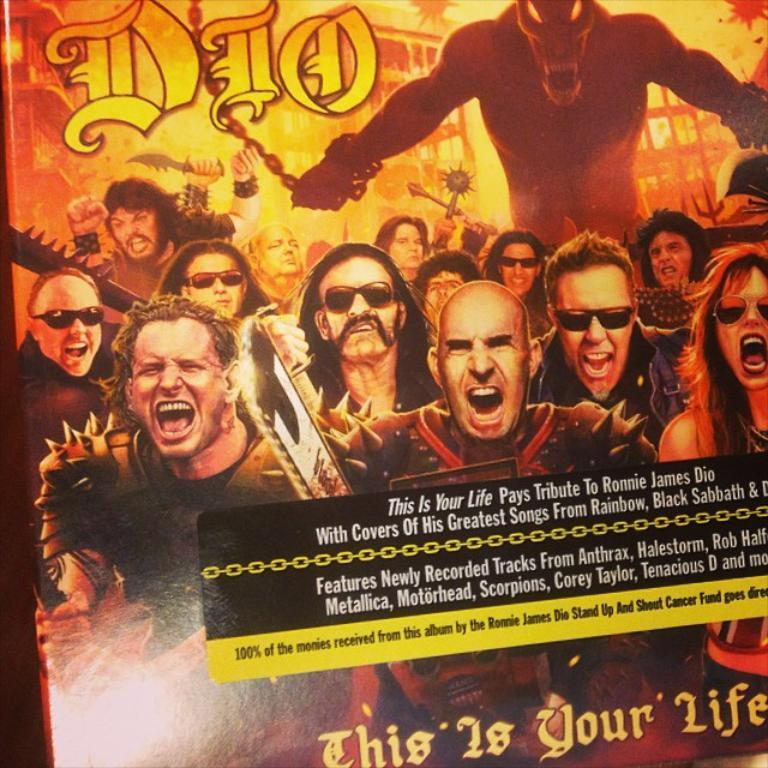What is the main subject of the image? There is an advertisement in the image. What time is displayed on the clock in the image? There is no clock present in the image; it only features an advertisement. 